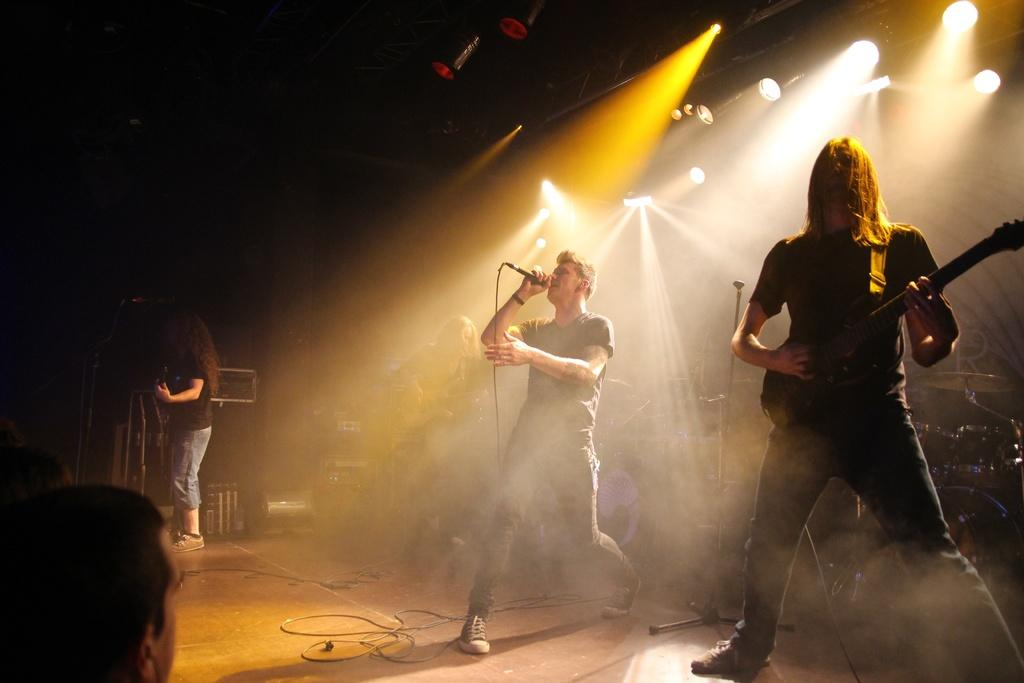What is the person in the image doing? The person is playing the guitar in the image. On which side of the image is the person playing the guitar? The person is playing the guitar over the right side of the image. What else is the person doing while playing the guitar? The person is singing. Can you describe another person in the image? Yes, there is a woman standing in the image. What type of suit is the air wearing in the image? There is no mention of an air or a suit in the image; it features a person playing the guitar and a woman standing nearby. 